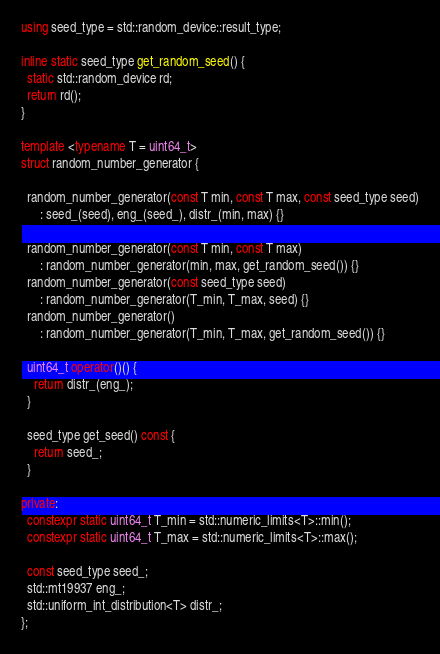Convert code to text. <code><loc_0><loc_0><loc_500><loc_500><_C++_>
using seed_type = std::random_device::result_type;

inline static seed_type get_random_seed() {
  static std::random_device rd;
  return rd();
}

template <typename T = uint64_t>
struct random_number_generator {

  random_number_generator(const T min, const T max, const seed_type seed)
      : seed_(seed), eng_(seed_), distr_(min, max) {}

  random_number_generator(const T min, const T max)
      : random_number_generator(min, max, get_random_seed()) {}
  random_number_generator(const seed_type seed)
      : random_number_generator(T_min, T_max, seed) {}
  random_number_generator()
      : random_number_generator(T_min, T_max, get_random_seed()) {}

  uint64_t operator()() {
    return distr_(eng_);
  }

  seed_type get_seed() const {
    return seed_;
  }

private:
  constexpr static uint64_t T_min = std::numeric_limits<T>::min();
  constexpr static uint64_t T_max = std::numeric_limits<T>::max();

  const seed_type seed_;
  std::mt19937 eng_;
  std::uniform_int_distribution<T> distr_;
};</code> 